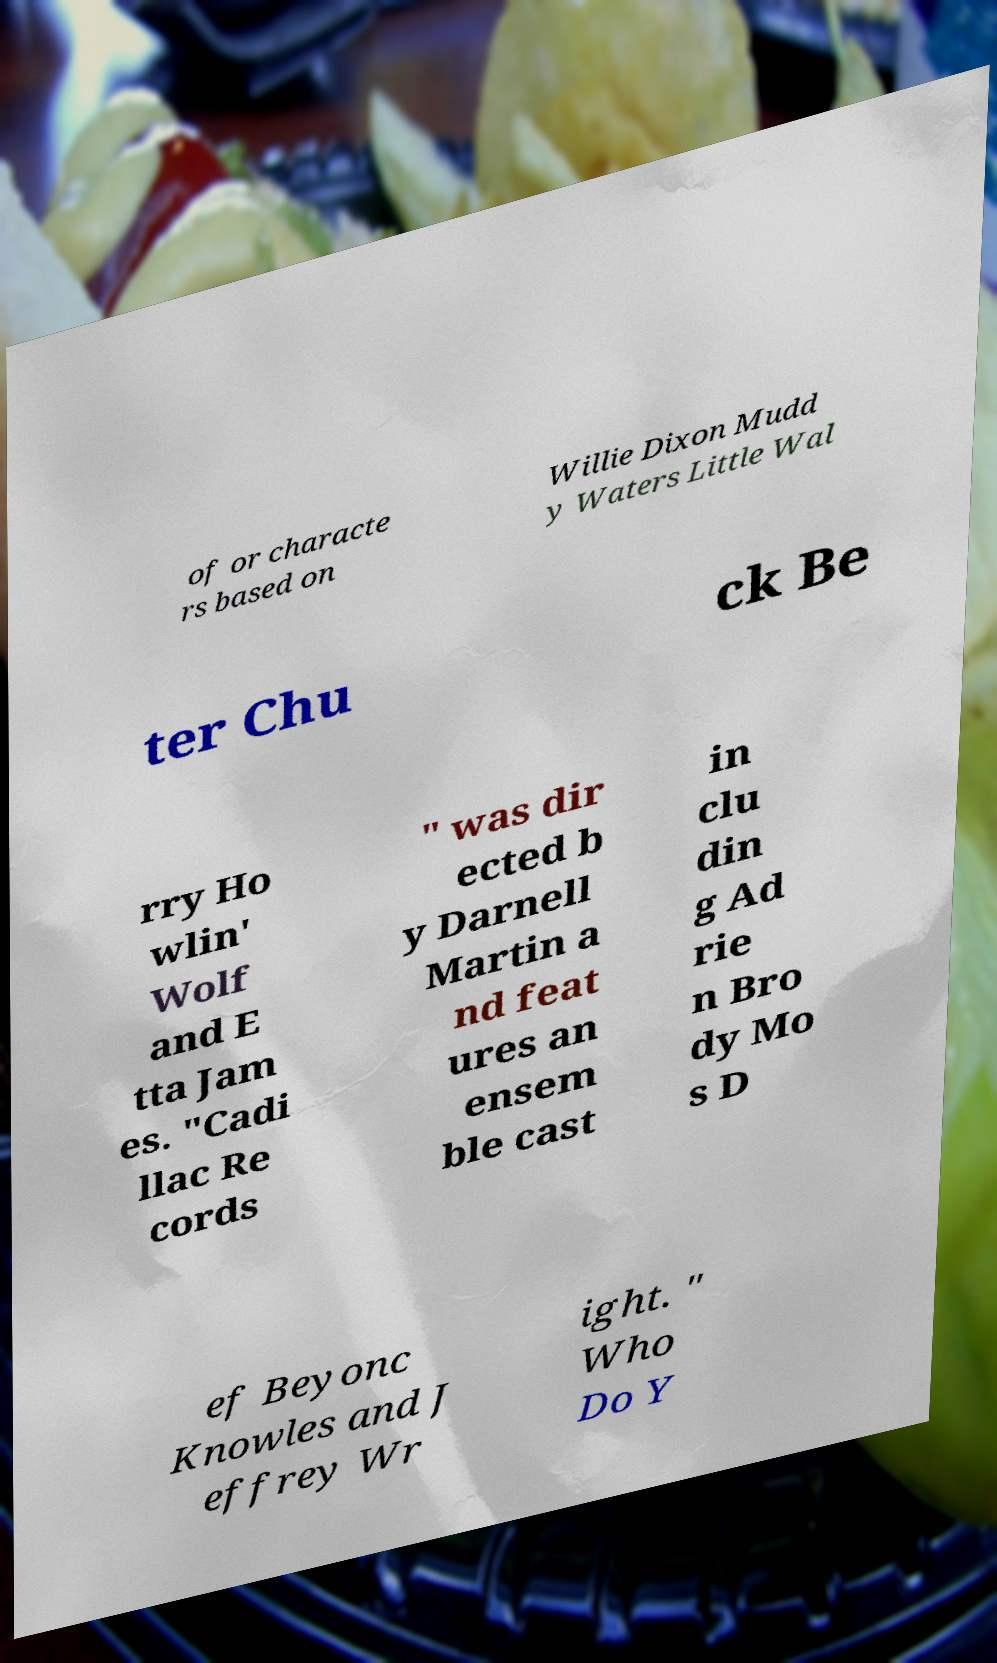What messages or text are displayed in this image? I need them in a readable, typed format. of or characte rs based on Willie Dixon Mudd y Waters Little Wal ter Chu ck Be rry Ho wlin' Wolf and E tta Jam es. "Cadi llac Re cords " was dir ected b y Darnell Martin a nd feat ures an ensem ble cast in clu din g Ad rie n Bro dy Mo s D ef Beyonc Knowles and J effrey Wr ight. " Who Do Y 